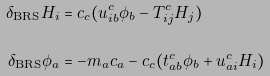<formula> <loc_0><loc_0><loc_500><loc_500>\delta _ { \text {BRS} } H _ { i } & = c _ { c } ( u ^ { c } _ { i b } \phi _ { b } - T ^ { c } _ { i j } H _ { j } ) \\ \delta _ { \text {BRS} } \phi _ { a } & = - m _ { a } c _ { a } - c _ { c } ( t ^ { c } _ { a b } \phi _ { b } + u ^ { c } _ { a i } H _ { i } )</formula> 